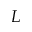Convert formula to latex. <formula><loc_0><loc_0><loc_500><loc_500>L</formula> 